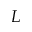Convert formula to latex. <formula><loc_0><loc_0><loc_500><loc_500>L</formula> 